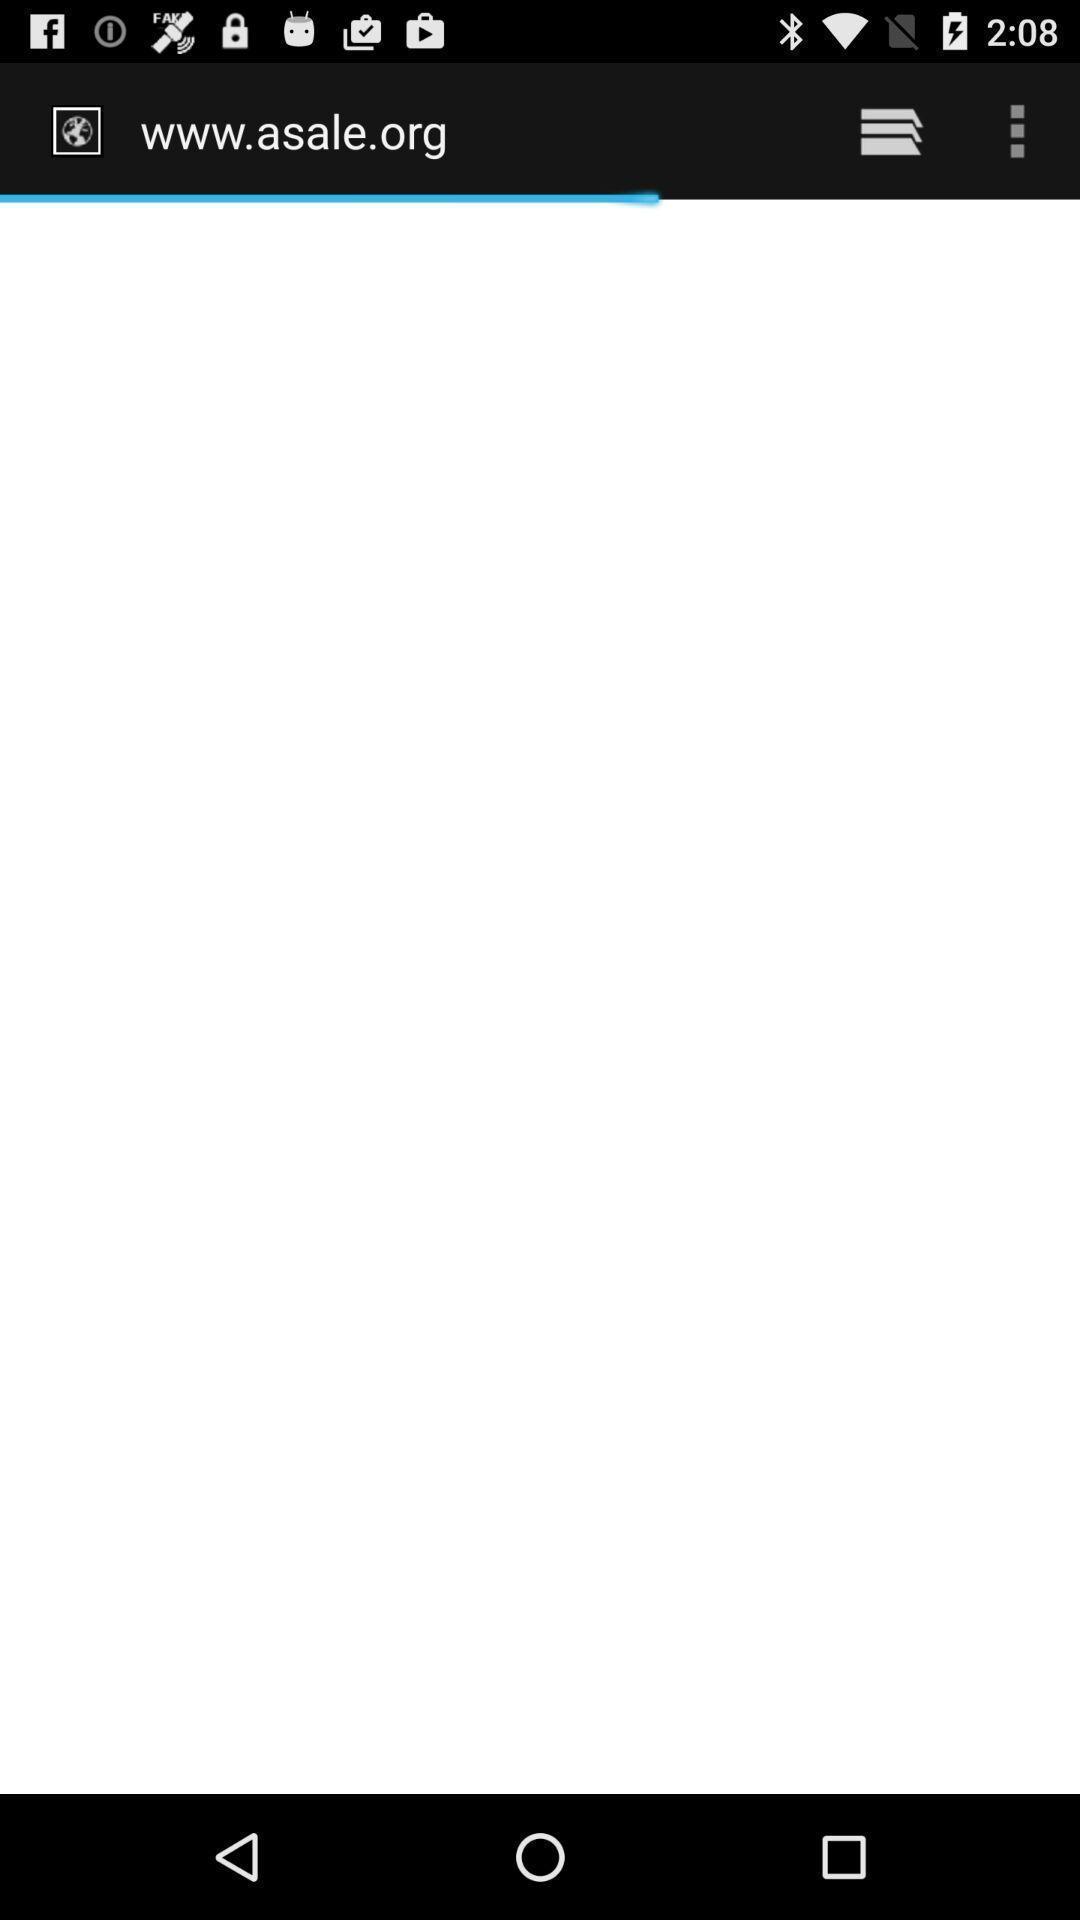Describe the key features of this screenshot. Screen displaying loading page. 